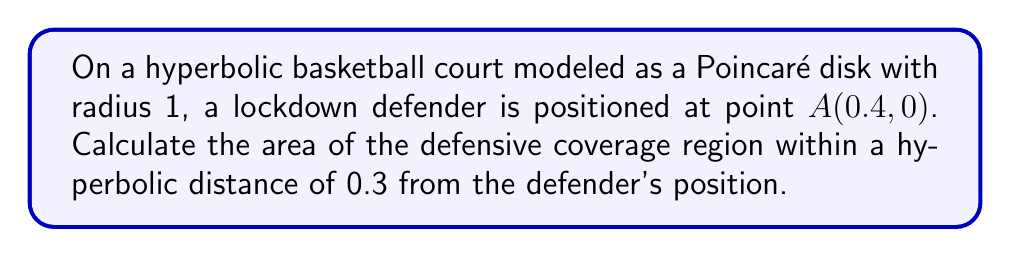Help me with this question. To solve this problem, we'll follow these steps:

1) In the Poincaré disk model of hyperbolic geometry, the area of a circle with hyperbolic radius $r$ centered at a point $(a, 0)$ is given by the formula:

   $$A = 4\pi \sinh^2(\frac{r}{2}) \cdot \frac{(1-a^2)^2}{(1+a^2+2a\cosh r)^2}$$

2) In our case:
   $a = 0.4$ (the x-coordinate of point $A$)
   $r = 0.3$ (the hyperbolic radius of the coverage area)

3) Let's substitute these values into the formula:

   $$A = 4\pi \sinh^2(\frac{0.3}{2}) \cdot \frac{(1-0.4^2)^2}{(1+0.4^2+2\cdot0.4\cosh 0.3)^2}$$

4) Now, let's calculate step by step:
   
   $\sinh^2(\frac{0.3}{2}) \approx 0.0225$
   
   $(1-0.4^2)^2 = 0.6^4 = 0.1296$
   
   $\cosh 0.3 \approx 1.0453$
   
   $(1+0.4^2+2\cdot0.4\cosh 0.3)^2 \approx (1.16+0.8361)^2 \approx 3.9841$

5) Substituting these values:

   $$A \approx 4\pi \cdot 0.0225 \cdot \frac{0.1296}{3.9841} \approx 0.0092$$

6) Therefore, the area of the defensive coverage region is approximately 0.0092 square units in the Poincaré disk model.
Answer: $0.0092$ square units 